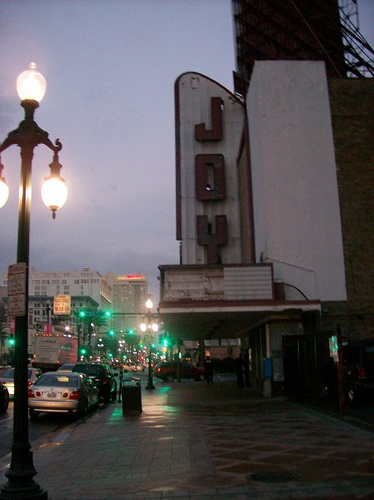Extract all visible text content from this image. JOY 